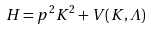<formula> <loc_0><loc_0><loc_500><loc_500>H = p ^ { 2 } K ^ { 2 } + V ( K , { \mathit \Lambda } )</formula> 